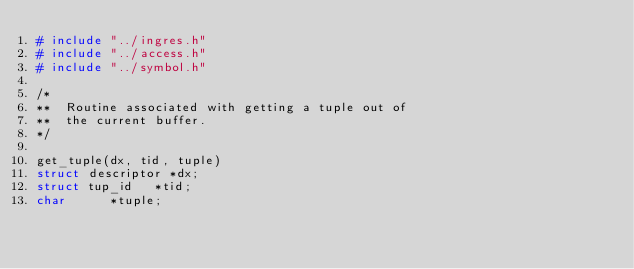<code> <loc_0><loc_0><loc_500><loc_500><_C_># include	"../ingres.h"
# include	"../access.h"
# include	"../symbol.h"

/*
**	Routine associated with getting a tuple out of
**	the current buffer.
*/

get_tuple(dx, tid, tuple)
struct descriptor	*dx;
struct tup_id		*tid;
char			*tuple;
</code> 